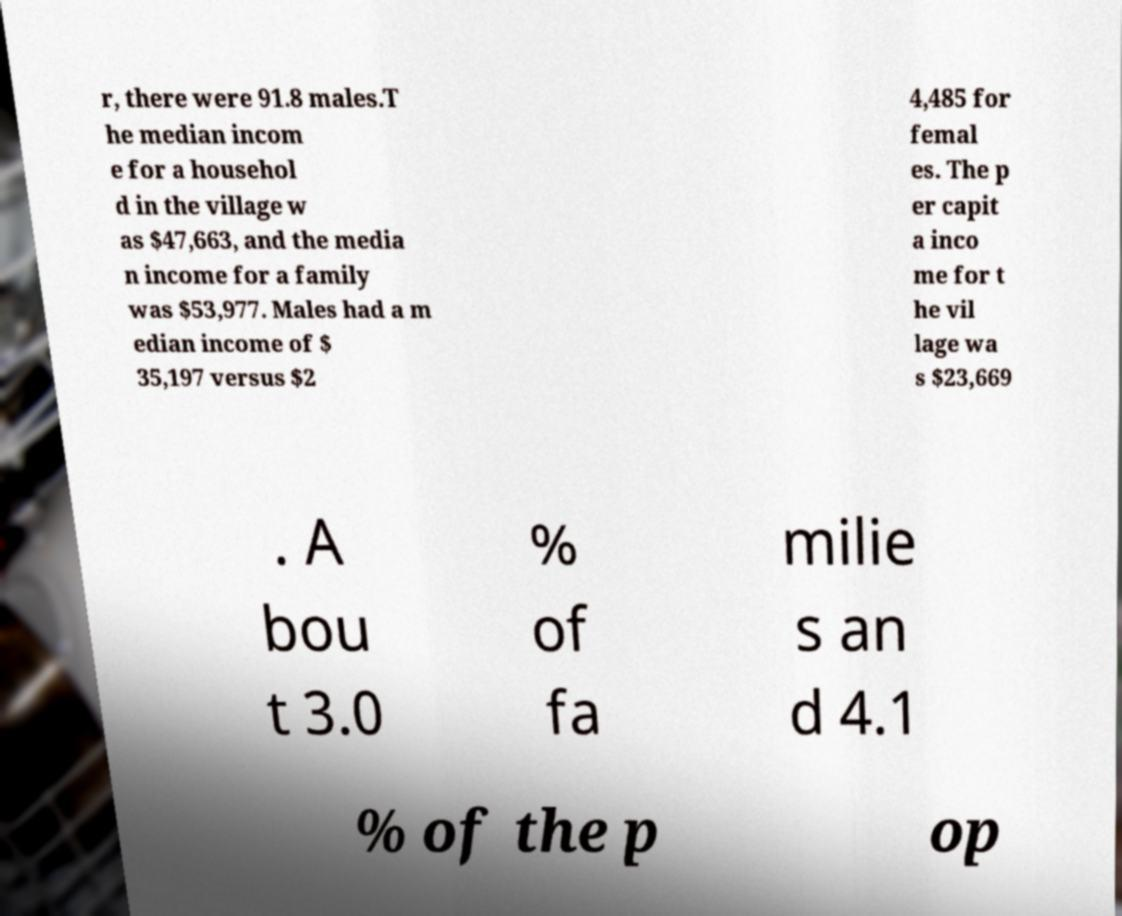What messages or text are displayed in this image? I need them in a readable, typed format. r, there were 91.8 males.T he median incom e for a househol d in the village w as $47,663, and the media n income for a family was $53,977. Males had a m edian income of $ 35,197 versus $2 4,485 for femal es. The p er capit a inco me for t he vil lage wa s $23,669 . A bou t 3.0 % of fa milie s an d 4.1 % of the p op 